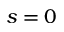Convert formula to latex. <formula><loc_0><loc_0><loc_500><loc_500>s = 0</formula> 